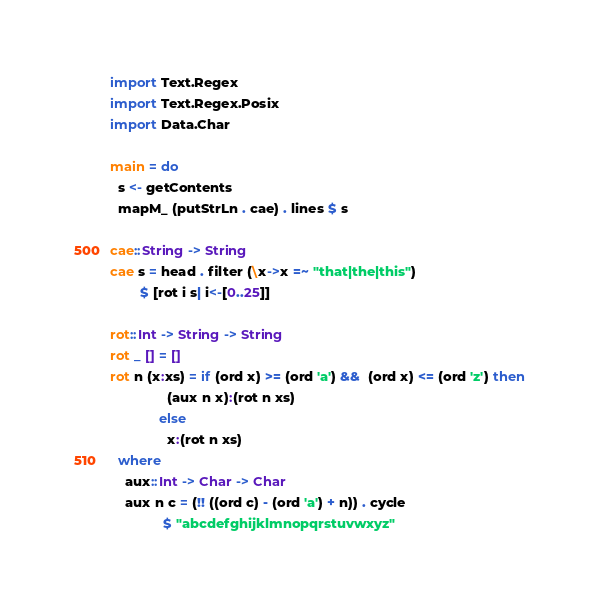Convert code to text. <code><loc_0><loc_0><loc_500><loc_500><_Haskell_>import Text.Regex
import Text.Regex.Posix
import Data.Char

main = do
  s <- getContents
  mapM_ (putStrLn . cae) . lines $ s

cae::String -> String
cae s = head . filter (\x->x =~ "that|the|this")
        $ [rot i s| i<-[0..25]]

rot::Int -> String -> String
rot _ [] = []
rot n (x:xs) = if (ord x) >= (ord 'a') &&  (ord x) <= (ord 'z') then
               (aux n x):(rot n xs)
             else
               x:(rot n xs)
  where
    aux::Int -> Char -> Char
    aux n c = (!! ((ord c) - (ord 'a') + n)) . cycle
              $ "abcdefghijklmnopqrstuvwxyz"</code> 